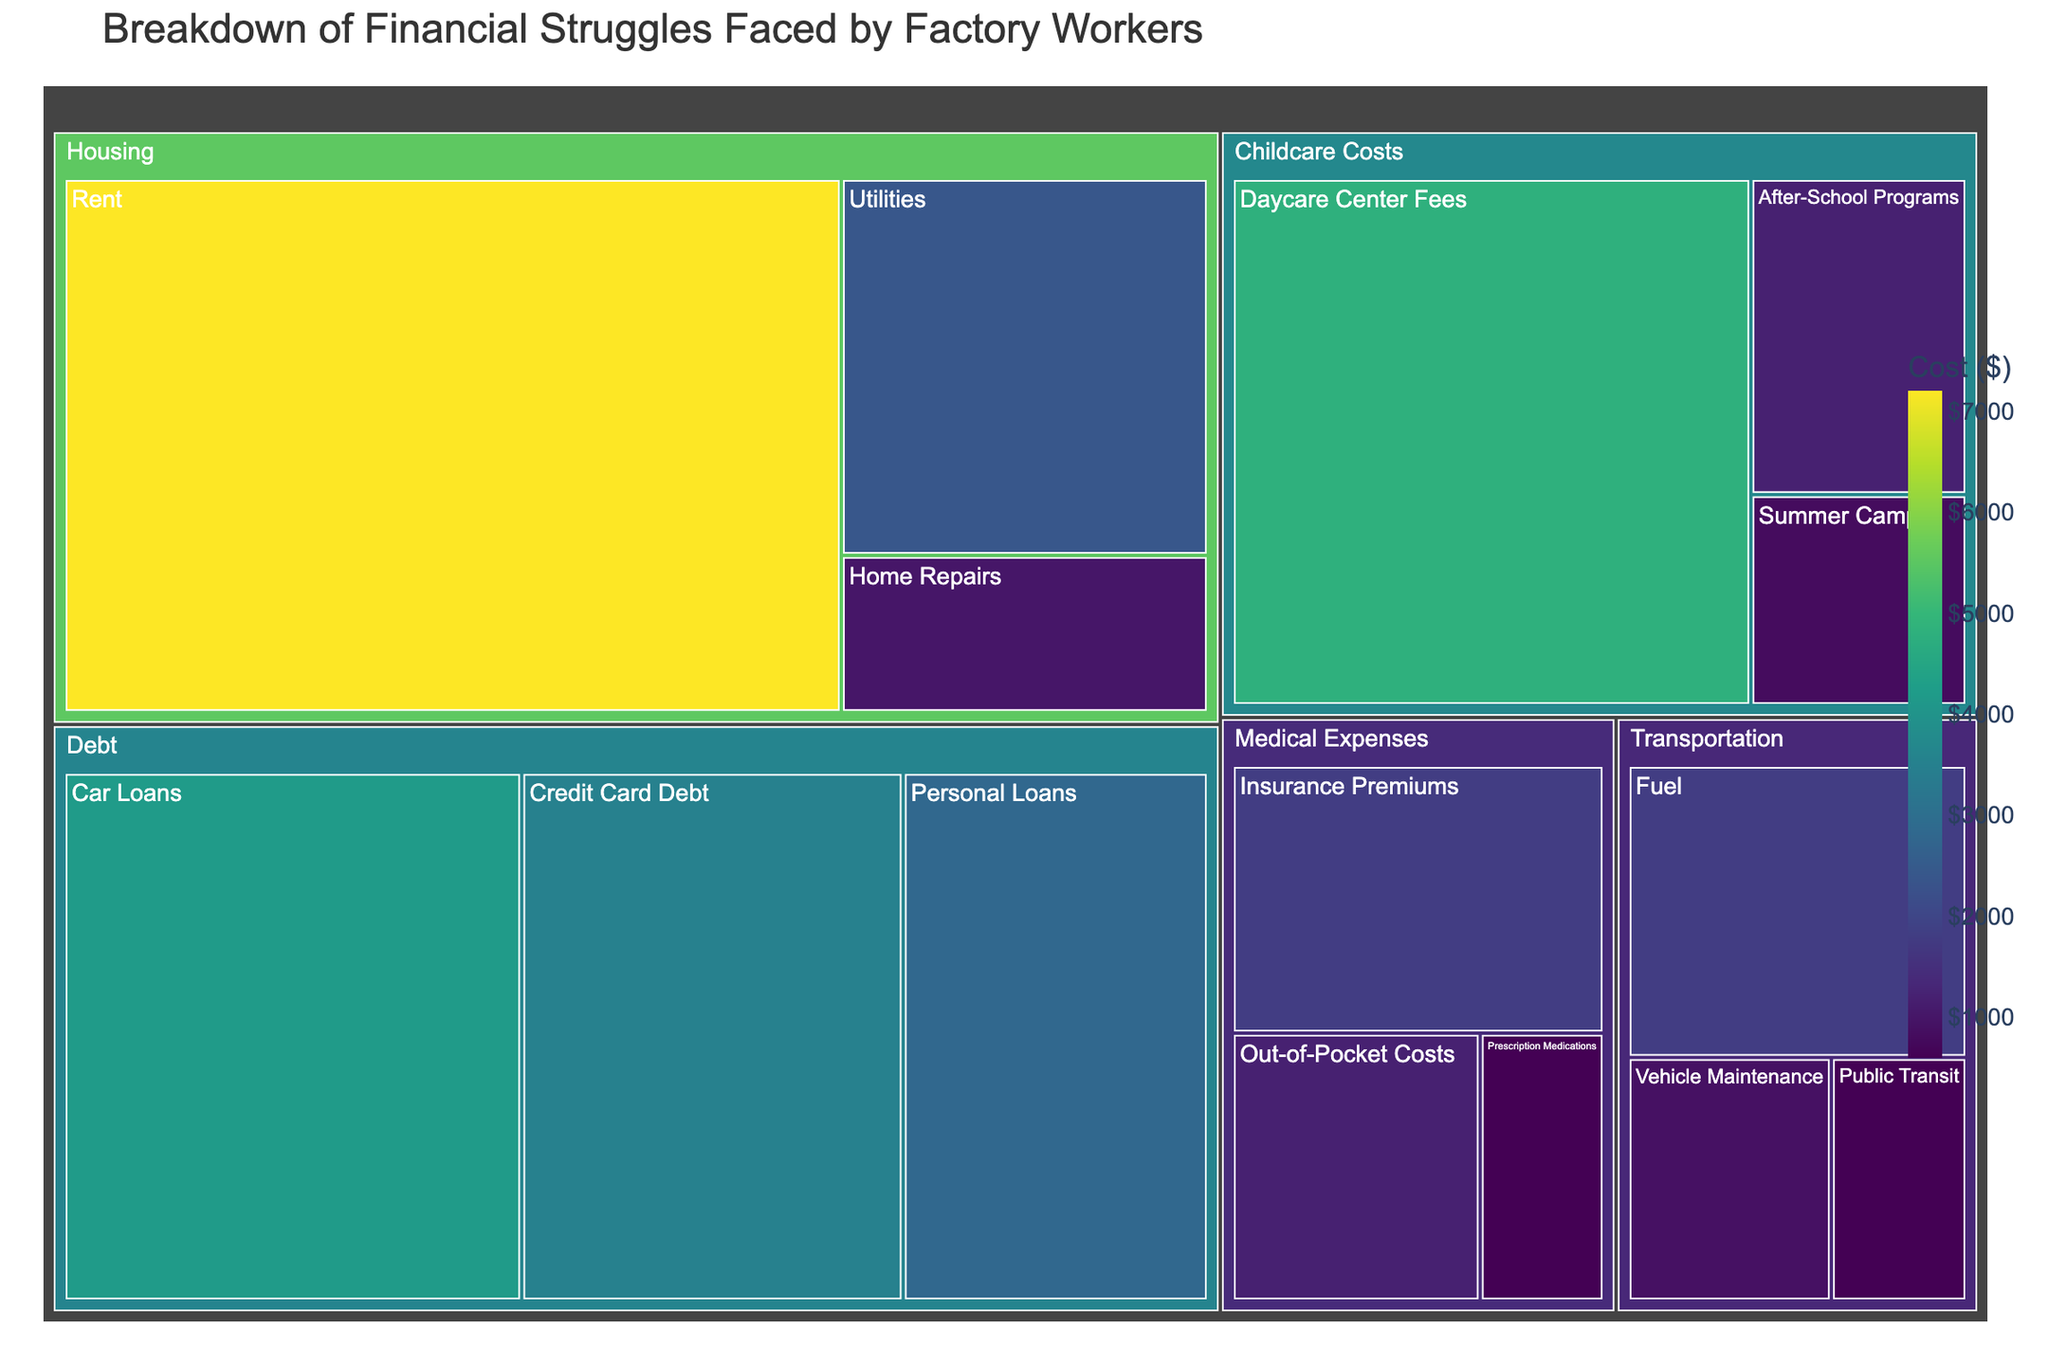What is the largest single expense in the treemap? The largest area in the treemap will represent the highest value. In this case, 'Rent' under 'Housing' has the largest area and a value of $7200.
Answer: Rent What are the total childcare costs combined? Add the values of all subcategories under 'Childcare Costs': Daycare Center Fees ($4800) + After-School Programs ($1200) + Summer Camps ($800). This gives a total of $4800 + $1200 + $800 = $6800.
Answer: $6800 Which category has the lowest total cost, and what is it? Comparing the total of each main category: Debt ($3500 + $2800 + $4200 = $10500), Medical Expenses ($1800 + $1200 + $600 = $3600), Childcare Costs ($6800), Housing ($7200 + $2400 + $1000 = $10600), Transportation ($1800 + $600 + $900 = $3300), Transportation has the lowest total.
Answer: Transportation What is the difference in cost between the highest and lowest subcategory in the 'Transportation' category? The highest value in 'Transportation' is Fuel ($1800), and the lowest is Public Transit ($600). The difference is $1800 - $600 = $1200.
Answer: $1200 Which has a higher cost, Credit Card Debt or Daycare Center Fees? Credit Card Debt and Daycare Center Fees are compared by their values. Credit Card Debt is $3500, while Daycare Center Fees is $4800. Daycare Center Fees is higher.
Answer: Daycare Center Fees What proportion of the total 'Debt' costs are from Car Loans? The total of 'Debt' costs is $3500 + $2800 + $4200 = $10500. The proportion for Car Loans is $4200 / $10500 ≈ 0.4, or 40%.
Answer: 40% Are medical expenses higher or lower than childcare costs? The total for Medical Expenses is $3600, and for Childcare Costs is $6800. Comparing these, Medical Expenses are lower than Childcare Costs.
Answer: Lower What's the combined total cost for all categories listed in the treemap? Summing all the values: $10500 (Debt) + $3600 (Medical Expenses) + $6800 (Childcare Costs) + $10600 (Housing) + $3300 (Transportation) results in $10500 + $3600 + $6800 + $10600 + $3300 = $34800.
Answer: $34800 